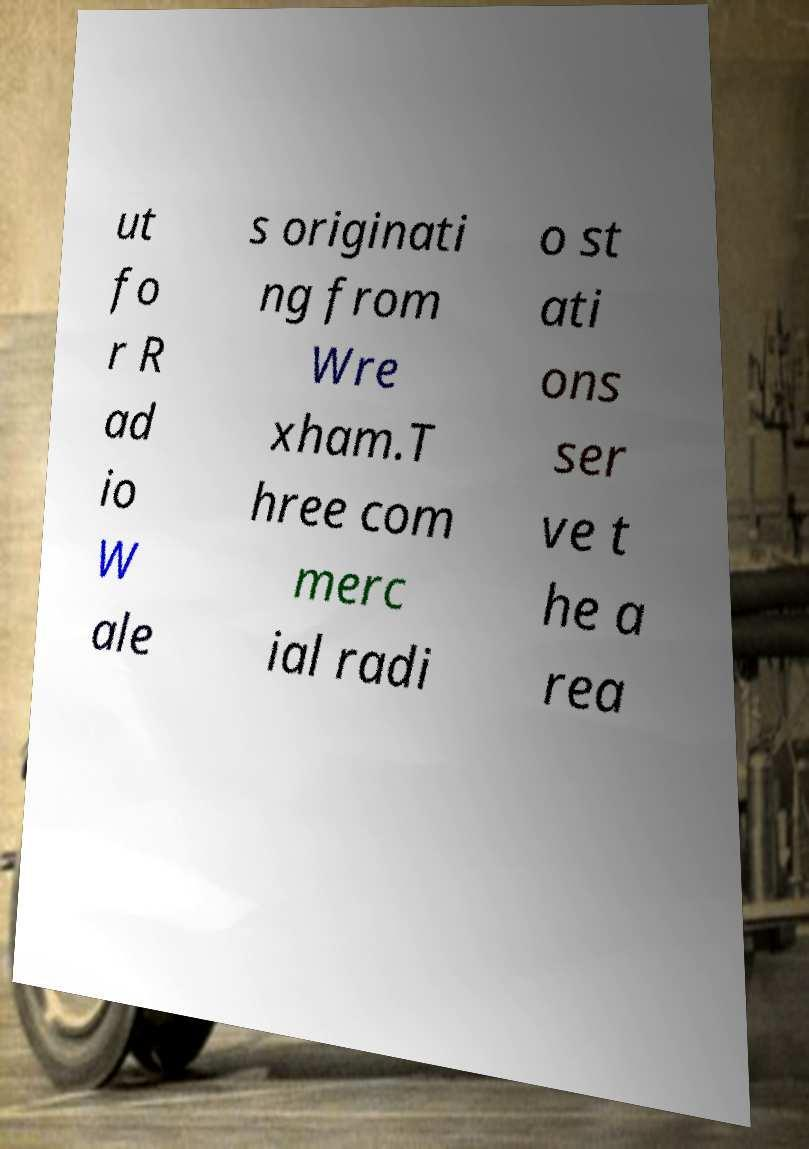What messages or text are displayed in this image? I need them in a readable, typed format. ut fo r R ad io W ale s originati ng from Wre xham.T hree com merc ial radi o st ati ons ser ve t he a rea 